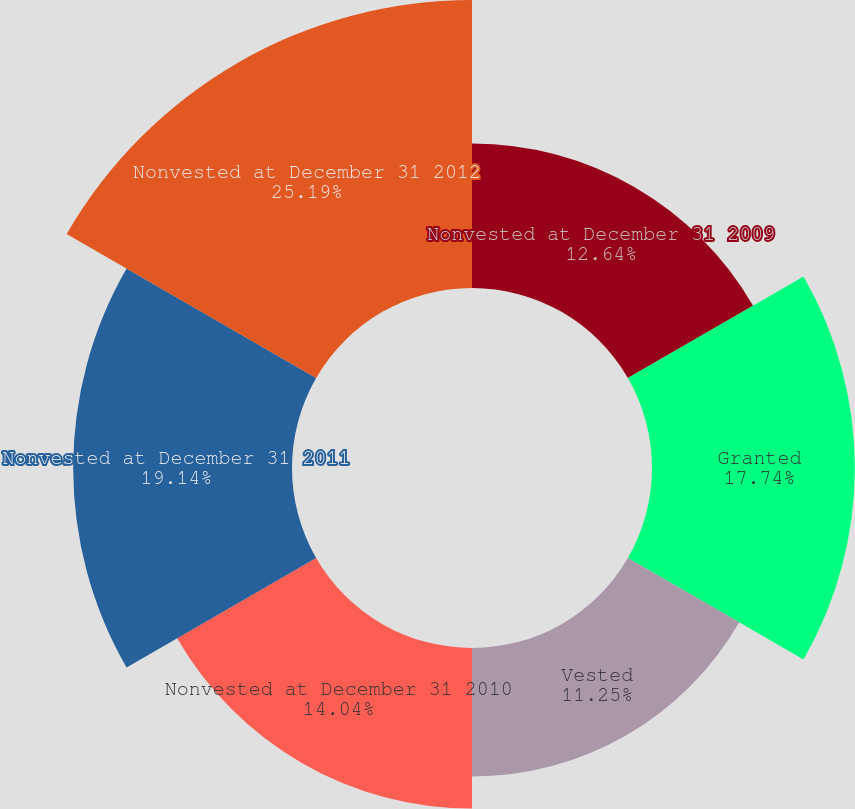Convert chart to OTSL. <chart><loc_0><loc_0><loc_500><loc_500><pie_chart><fcel>Nonvested at December 31 2009<fcel>Granted<fcel>Vested<fcel>Nonvested at December 31 2010<fcel>Nonvested at December 31 2011<fcel>Nonvested at December 31 2012<nl><fcel>12.64%<fcel>17.74%<fcel>11.25%<fcel>14.04%<fcel>19.14%<fcel>25.19%<nl></chart> 